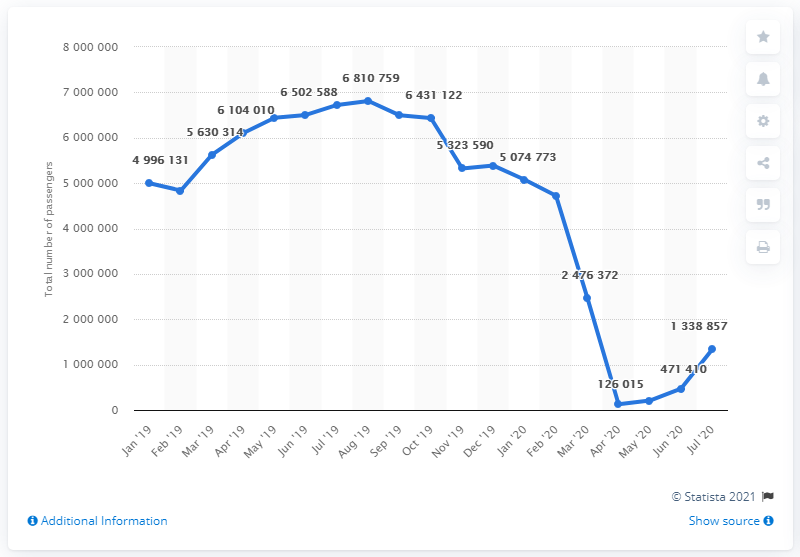List a handful of essential elements in this visual. The maximum number of passengers allowed is 6810759... April 2020 is the month with the least value among the given periods. 